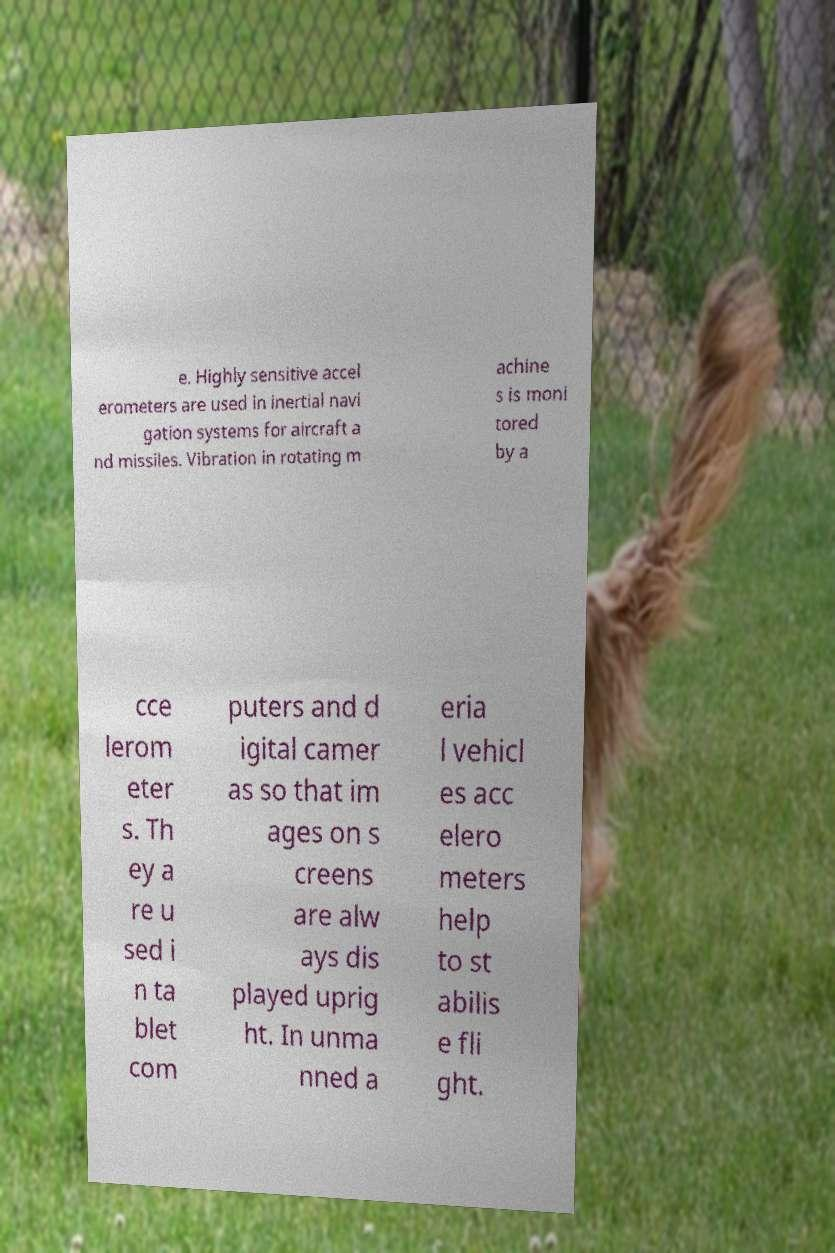I need the written content from this picture converted into text. Can you do that? e. Highly sensitive accel erometers are used in inertial navi gation systems for aircraft a nd missiles. Vibration in rotating m achine s is moni tored by a cce lerom eter s. Th ey a re u sed i n ta blet com puters and d igital camer as so that im ages on s creens are alw ays dis played uprig ht. In unma nned a eria l vehicl es acc elero meters help to st abilis e fli ght. 